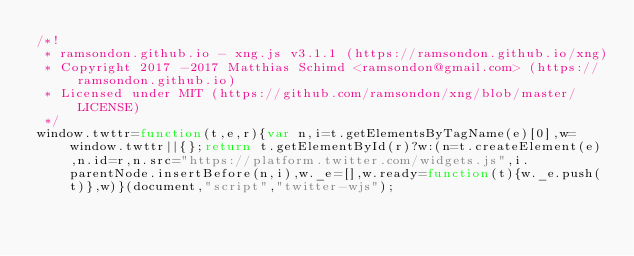Convert code to text. <code><loc_0><loc_0><loc_500><loc_500><_JavaScript_>/*!
 * ramsondon.github.io - xng.js v3.1.1 (https://ramsondon.github.io/xng)
 * Copyright 2017 -2017 Matthias Schimd <ramsondon@gmail.com> (https://ramsondon.github.io)
 * Licensed under MIT (https://github.com/ramsondon/xng/blob/master/LICENSE)
 */
window.twttr=function(t,e,r){var n,i=t.getElementsByTagName(e)[0],w=window.twttr||{};return t.getElementById(r)?w:(n=t.createElement(e),n.id=r,n.src="https://platform.twitter.com/widgets.js",i.parentNode.insertBefore(n,i),w._e=[],w.ready=function(t){w._e.push(t)},w)}(document,"script","twitter-wjs");</code> 